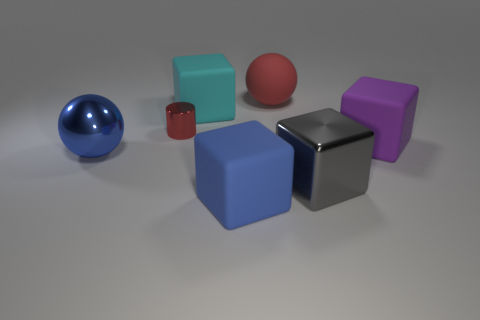What is the size of the cylinder that is the same material as the large blue ball?
Offer a very short reply. Small. What is the cyan cube made of?
Your response must be concise. Rubber. What number of red spheres have the same size as the cyan object?
Your answer should be very brief. 1. There is a big object that is the same color as the tiny cylinder; what shape is it?
Offer a terse response. Sphere. Is there a brown metallic thing of the same shape as the purple rubber thing?
Make the answer very short. No. There is a metal block that is the same size as the purple rubber object; what is its color?
Provide a succinct answer. Gray. What is the color of the big matte thing in front of the large metallic object that is to the left of the big rubber sphere?
Make the answer very short. Blue. There is a ball right of the large cyan rubber cube; is its color the same as the tiny metallic object?
Make the answer very short. Yes. There is a shiny object that is behind the big purple matte cube to the right of the large cube that is behind the big purple block; what is its shape?
Your response must be concise. Cylinder. How many big cubes are to the left of the metal object that is behind the big blue metal thing?
Keep it short and to the point. 0. 